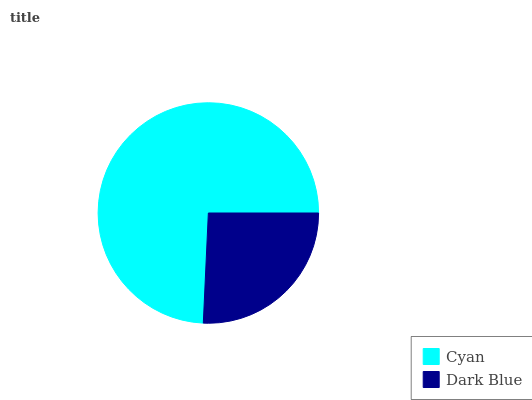Is Dark Blue the minimum?
Answer yes or no. Yes. Is Cyan the maximum?
Answer yes or no. Yes. Is Dark Blue the maximum?
Answer yes or no. No. Is Cyan greater than Dark Blue?
Answer yes or no. Yes. Is Dark Blue less than Cyan?
Answer yes or no. Yes. Is Dark Blue greater than Cyan?
Answer yes or no. No. Is Cyan less than Dark Blue?
Answer yes or no. No. Is Cyan the high median?
Answer yes or no. Yes. Is Dark Blue the low median?
Answer yes or no. Yes. Is Dark Blue the high median?
Answer yes or no. No. Is Cyan the low median?
Answer yes or no. No. 